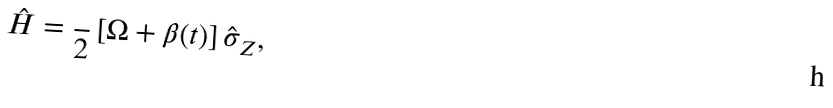Convert formula to latex. <formula><loc_0><loc_0><loc_500><loc_500>\hat { H } = \frac { } { 2 } \left [ \Omega + \beta ( t ) \right ] \hat { \sigma } _ { Z } ,</formula> 